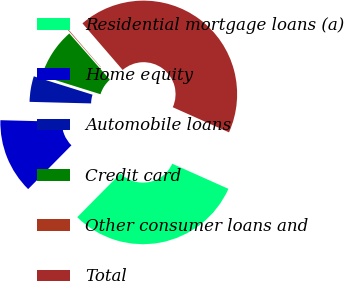<chart> <loc_0><loc_0><loc_500><loc_500><pie_chart><fcel>Residential mortgage loans (a)<fcel>Home equity<fcel>Automobile loans<fcel>Credit card<fcel>Other consumer loans and<fcel>Total<nl><fcel>30.72%<fcel>13.0%<fcel>4.42%<fcel>8.71%<fcel>0.13%<fcel>43.03%<nl></chart> 